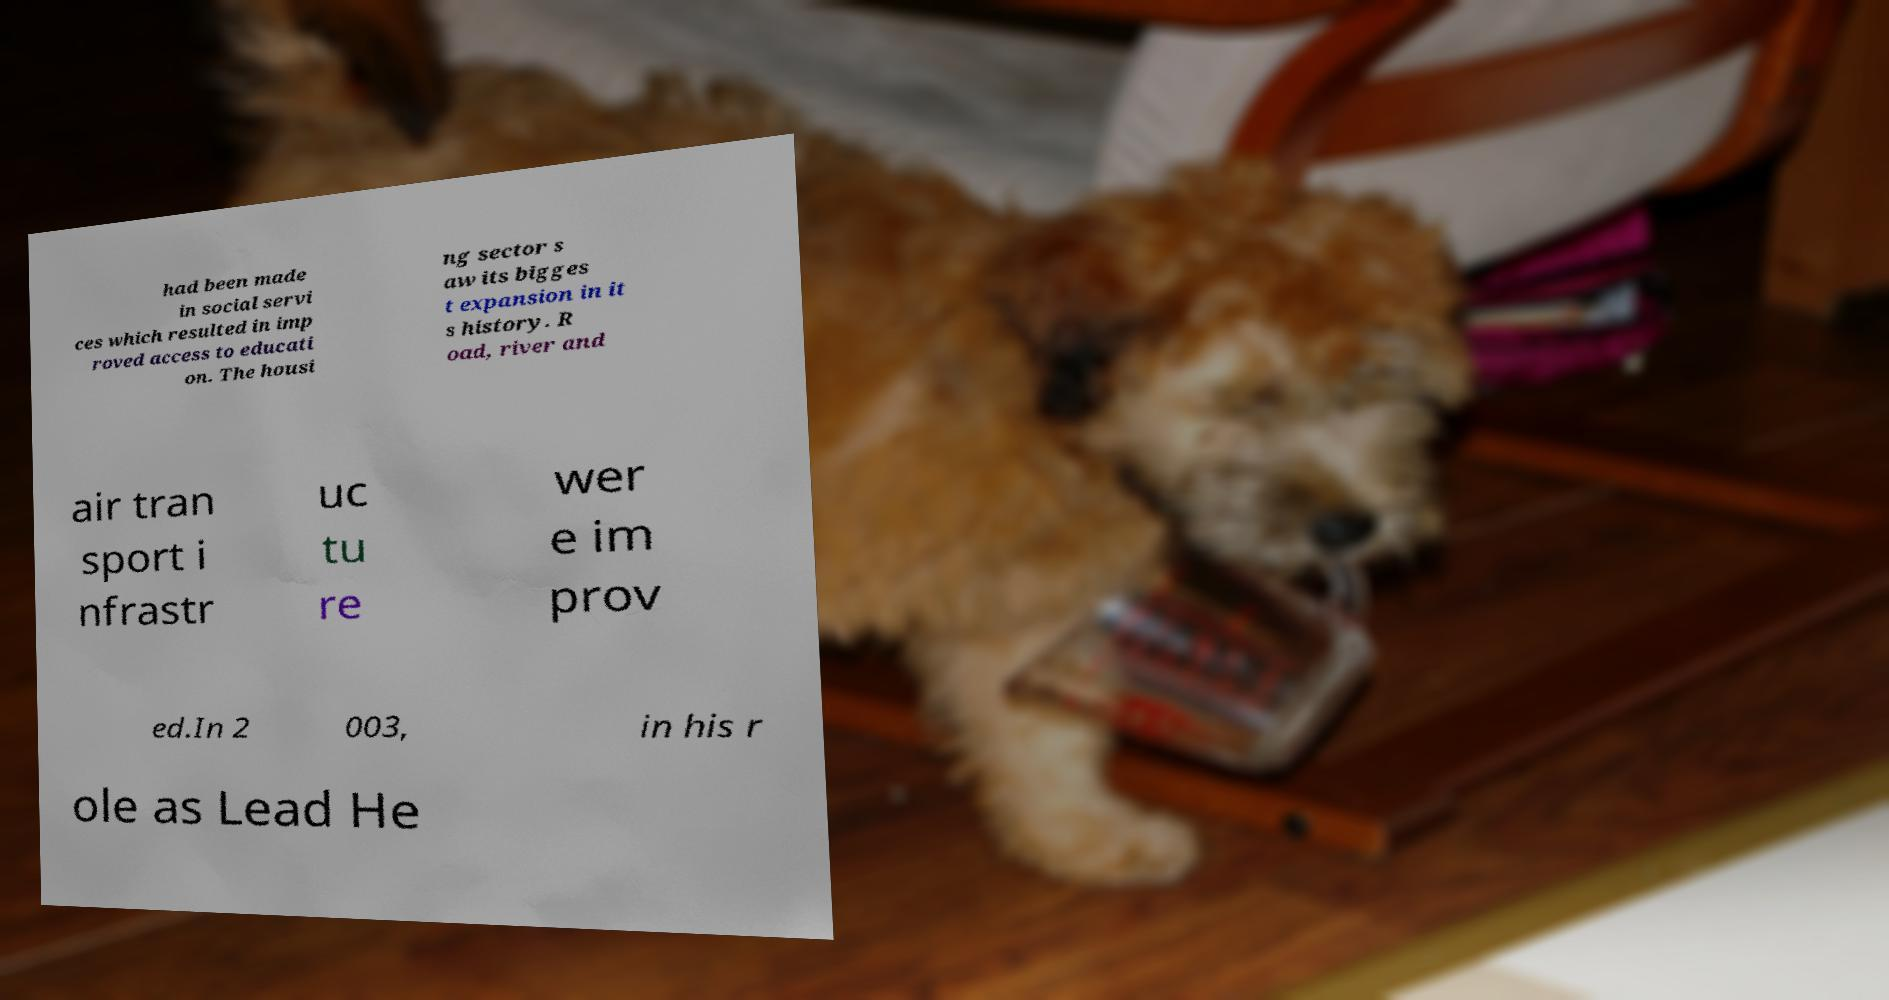Please identify and transcribe the text found in this image. had been made in social servi ces which resulted in imp roved access to educati on. The housi ng sector s aw its bigges t expansion in it s history. R oad, river and air tran sport i nfrastr uc tu re wer e im prov ed.In 2 003, in his r ole as Lead He 